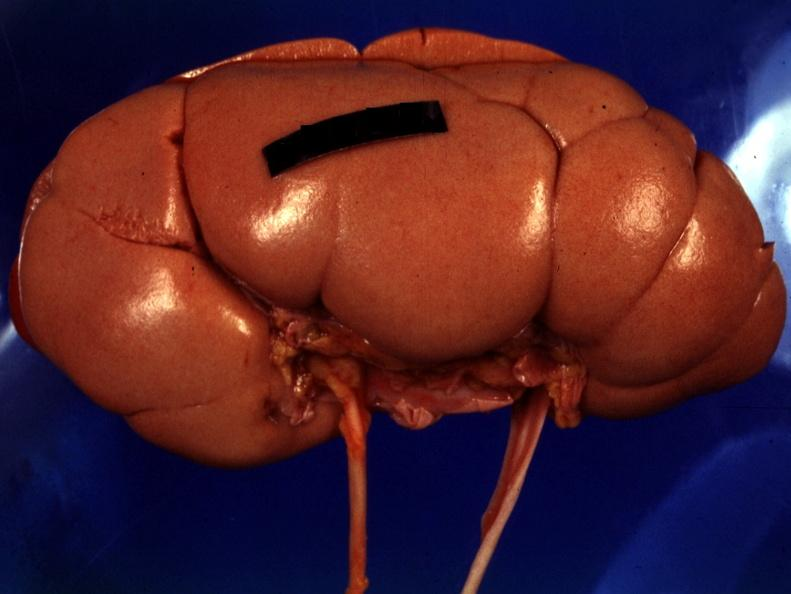s close-up tumor present?
Answer the question using a single word or phrase. No 